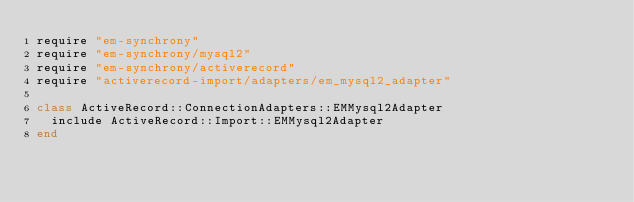<code> <loc_0><loc_0><loc_500><loc_500><_Ruby_>require "em-synchrony"
require "em-synchrony/mysql2"
require "em-synchrony/activerecord"
require "activerecord-import/adapters/em_mysql2_adapter"

class ActiveRecord::ConnectionAdapters::EMMysql2Adapter
  include ActiveRecord::Import::EMMysql2Adapter
end
</code> 